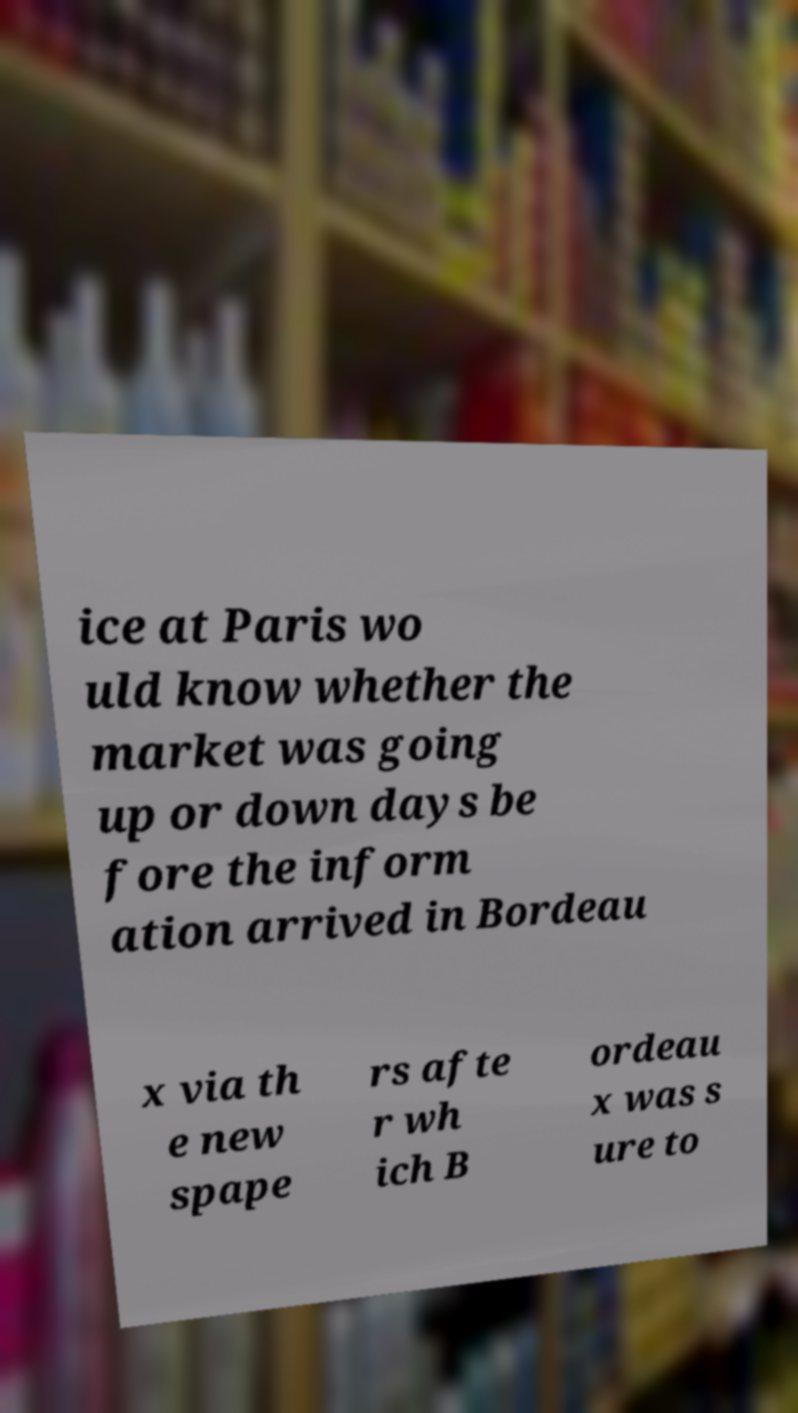Please read and relay the text visible in this image. What does it say? ice at Paris wo uld know whether the market was going up or down days be fore the inform ation arrived in Bordeau x via th e new spape rs afte r wh ich B ordeau x was s ure to 